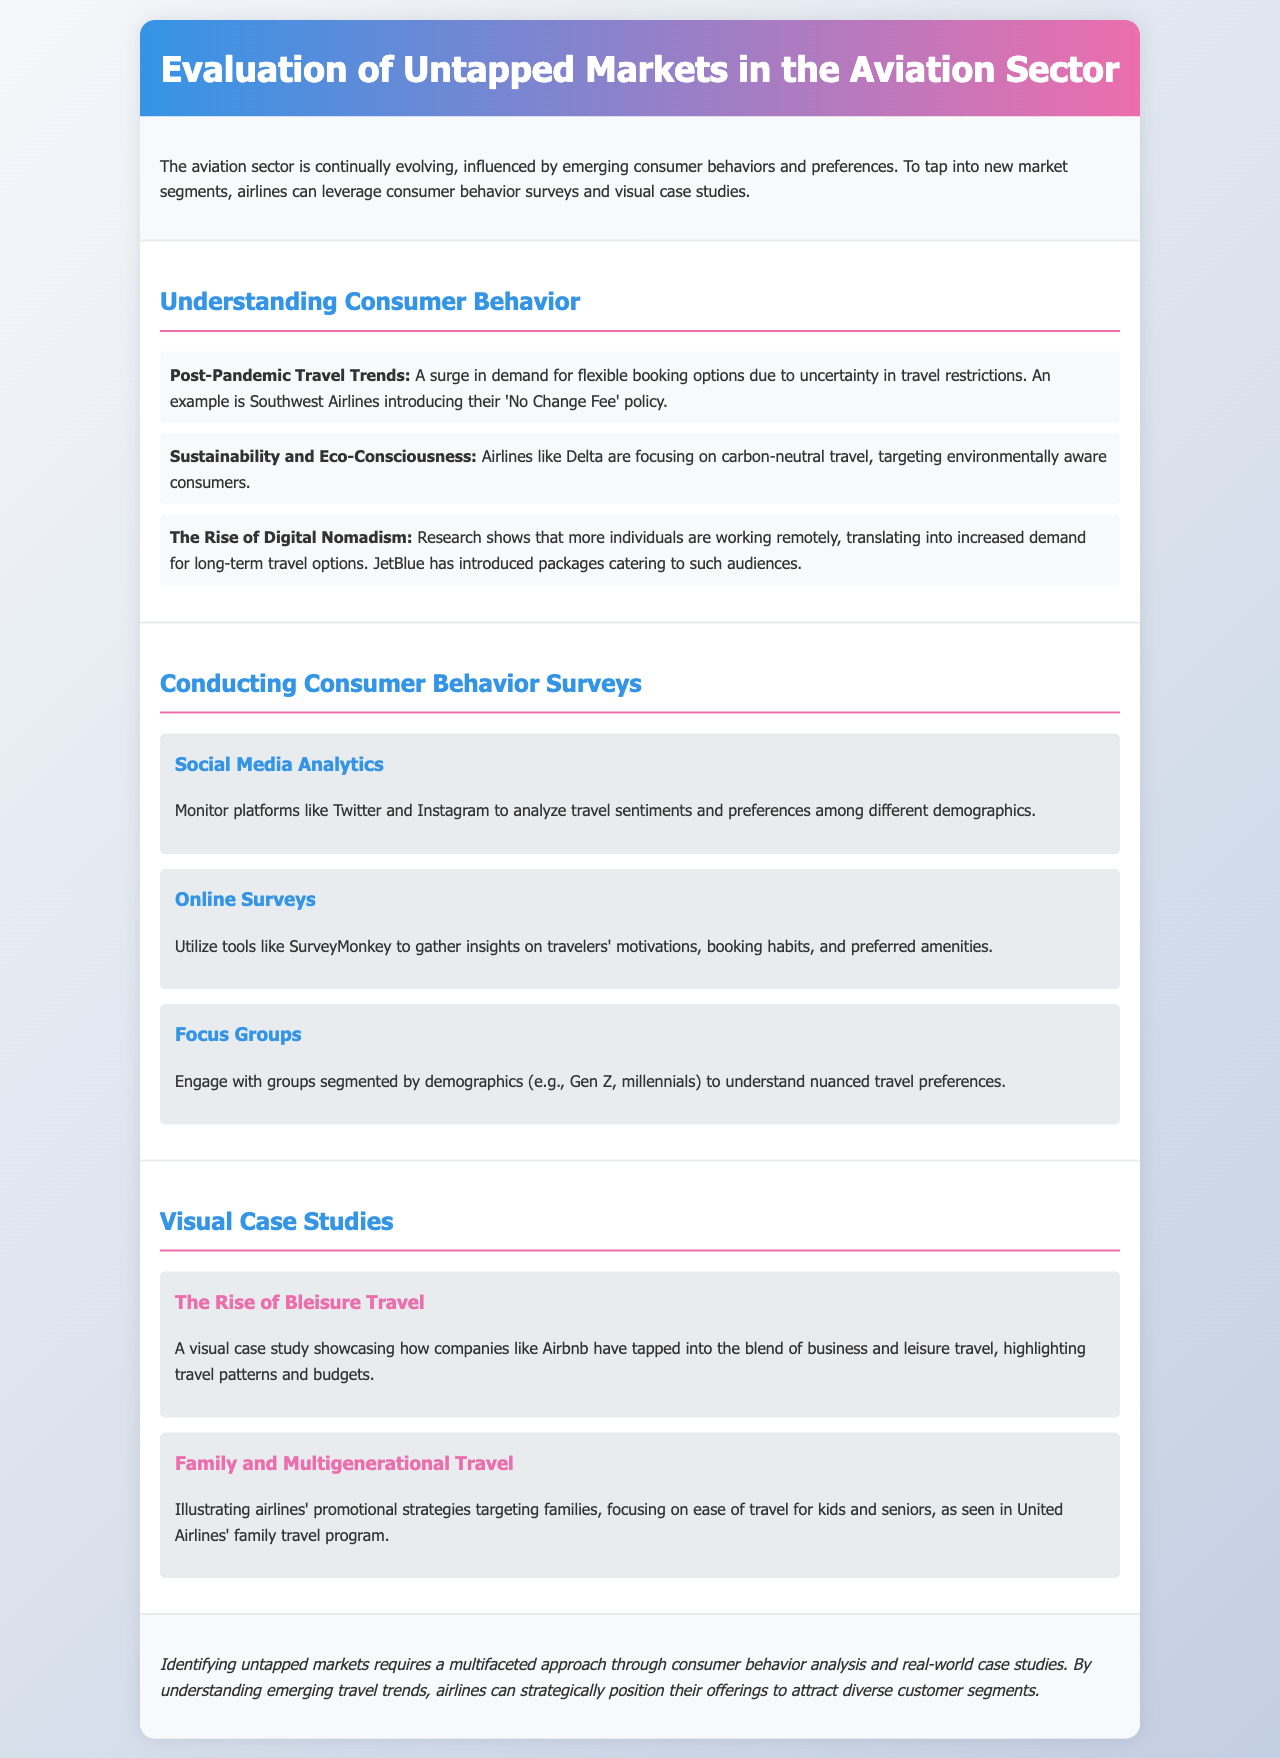What is the title of the document? The title of the document appears in the header section, summarizing its focus on untapped markets in aviation.
Answer: Evaluation of Untapped Markets in the Aviation Sector Which airline introduced a 'No Change Fee' policy? This information is mentioned under the Post-Pandemic Travel Trends section, where airlines are adapting to new traveler needs.
Answer: Southwest Airlines What consumer trend is targeted by Delta Airlines? This trend is discussed under Sustainability and Eco-Consciousness, where Delta focuses on eco-aware consumers.
Answer: Carbon-neutral travel Which online tool is recommended for gathering traveler insights? The method section discusses various tools, specifically named for online surveys.
Answer: SurveyMonkey What type of travel does JetBlue cater to? This detail is included in the section discussing post-pandemic travel trends and new market demands.
Answer: Long-term travel options What does the case study on Bleisure Travel focus on? This case study highlights a specific travel trend and the strategies companies use to address it.
Answer: Business and leisure travel Which airline's promotional strategy is illustrated for families? This example is included in the visual case studies section, focusing on family travel.
Answer: United Airlines What is the main approach to identifying untapped markets? This conclusion summarizes how airlines can best position themselves in emerging markets through analysis.
Answer: Multifaceted approach 